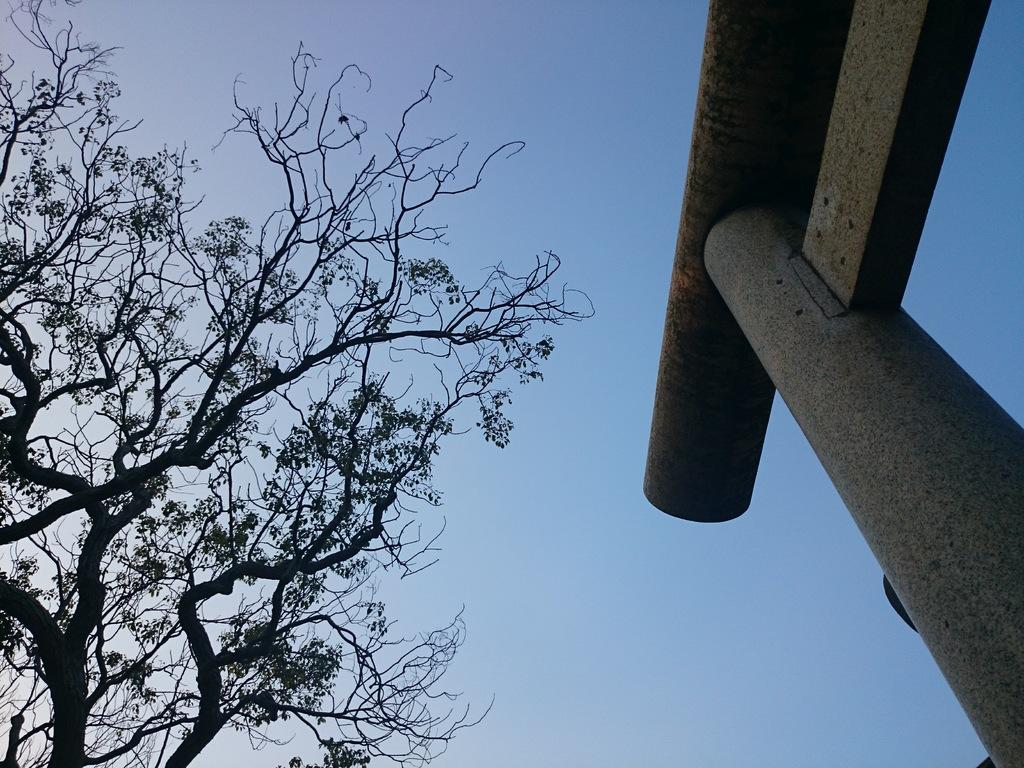What structure is located on the right side of the image? There is a pillar on the right side of the image. What type of vegetation is on the left side of the image? There is a tree on the left side of the image. What is visible in the background of the image? The sky is visible in the background of the image. Can you see a zephyr playing with a monkey on a twig in the image? There is no zephyr, monkey, or twig present in the image. 